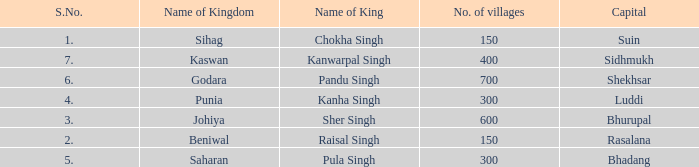Which kingdom has Suin as its capital? Sihag. 